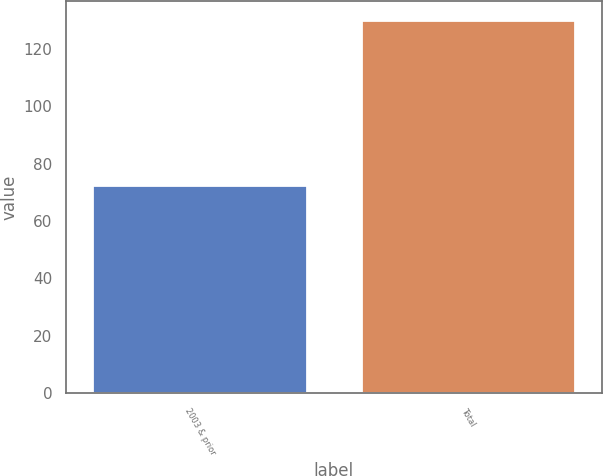<chart> <loc_0><loc_0><loc_500><loc_500><bar_chart><fcel>2003 & prior<fcel>Total<nl><fcel>72.5<fcel>130.2<nl></chart> 